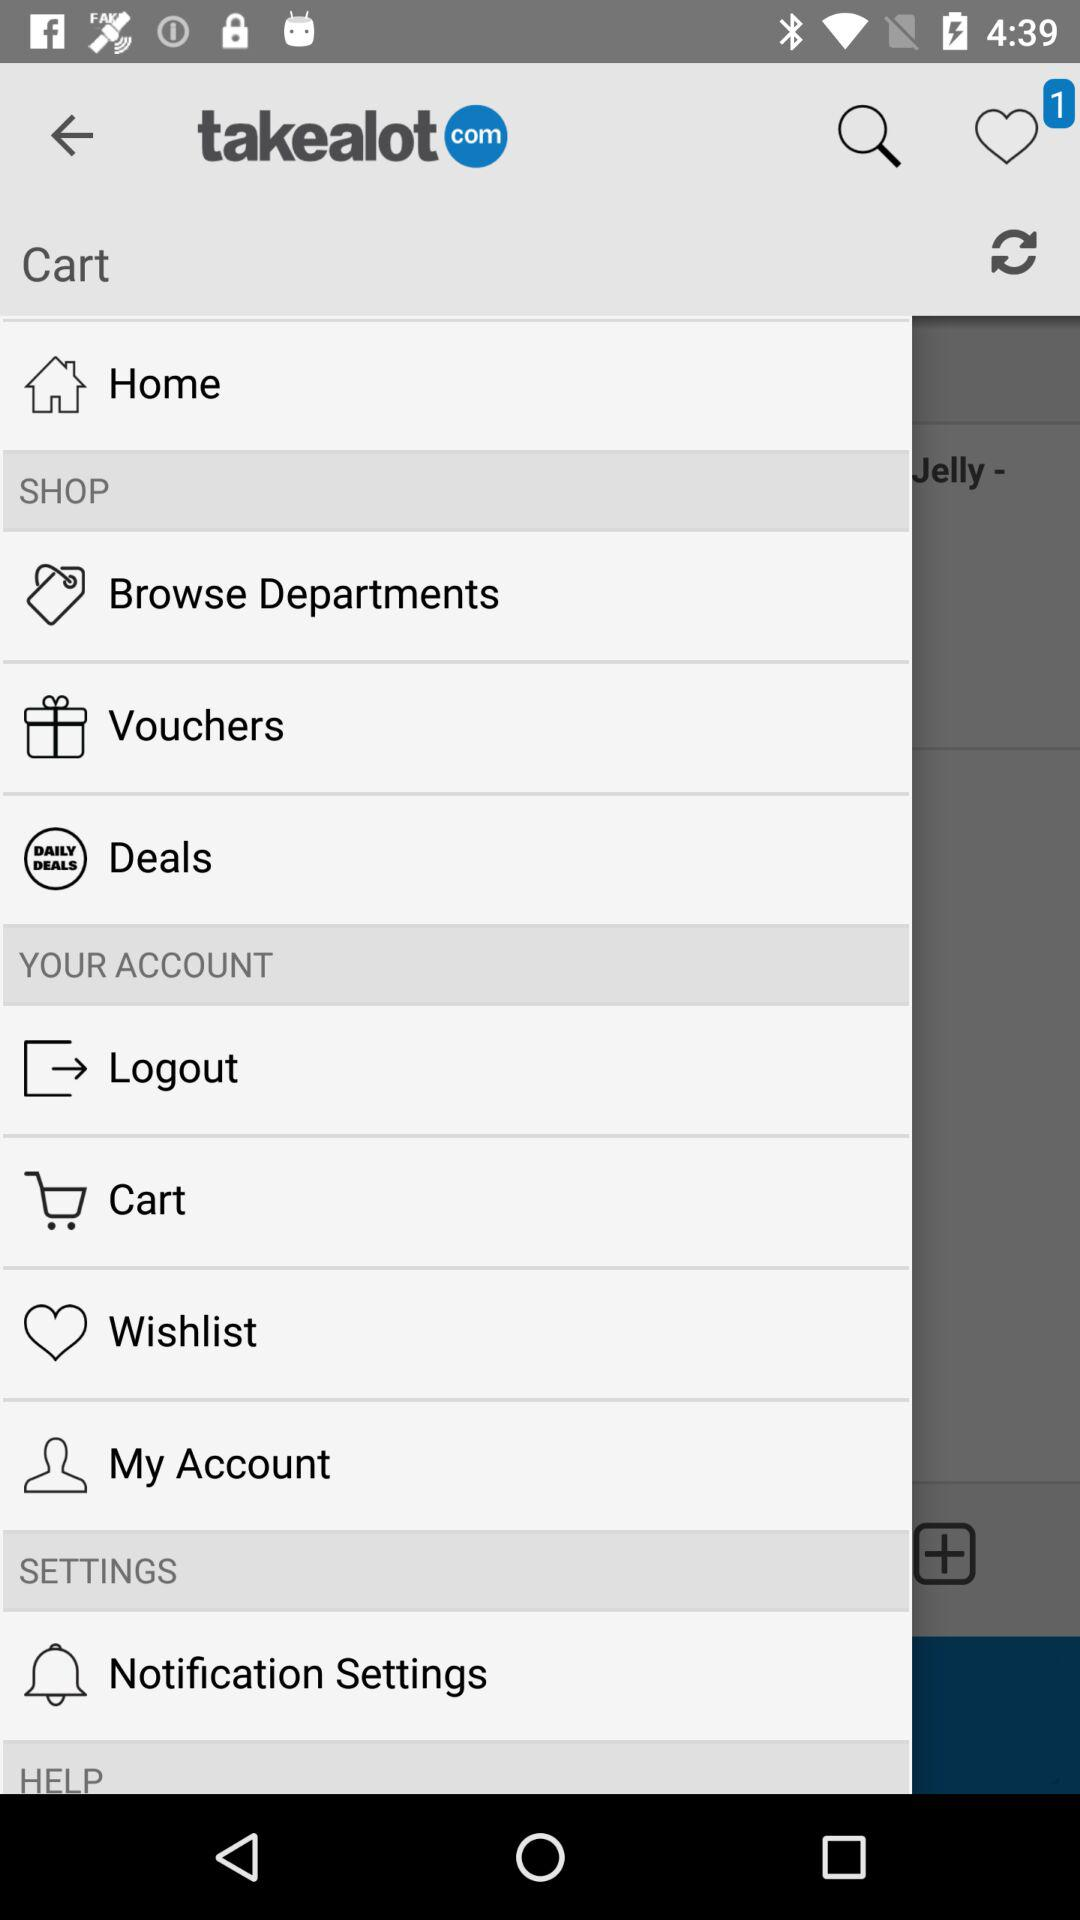How many notifications are on "like"? There is 1 notification. 